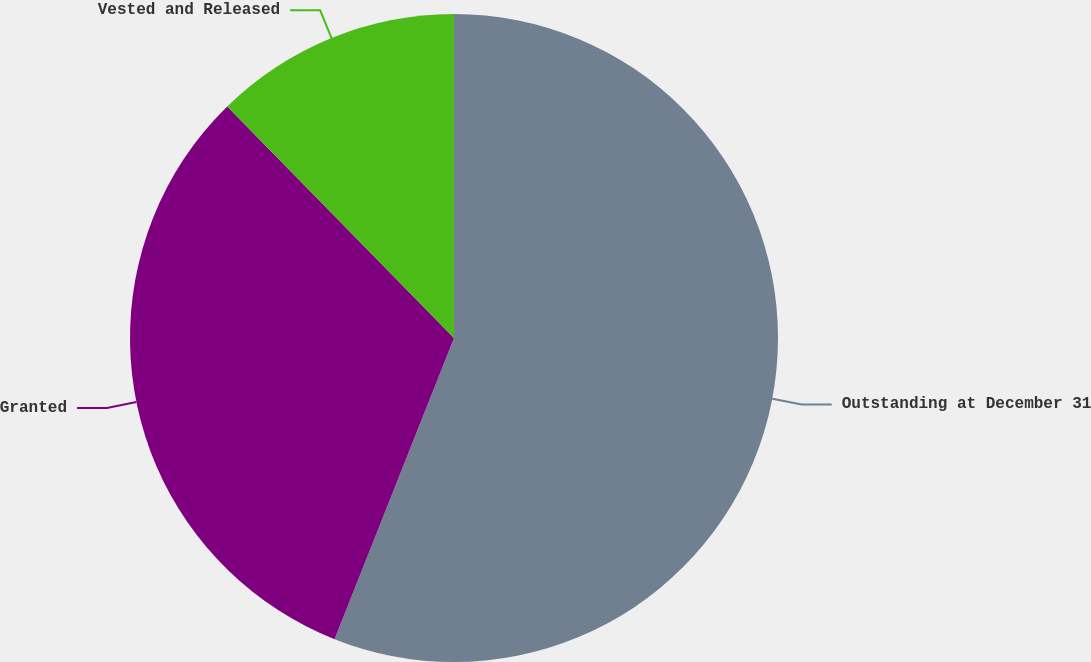Convert chart. <chart><loc_0><loc_0><loc_500><loc_500><pie_chart><fcel>Outstanding at December 31<fcel>Granted<fcel>Vested and Released<nl><fcel>56.01%<fcel>31.65%<fcel>12.34%<nl></chart> 